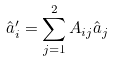Convert formula to latex. <formula><loc_0><loc_0><loc_500><loc_500>\hat { a } _ { i } ^ { \prime } = \sum _ { j = 1 } ^ { 2 } A _ { i j } \hat { a } _ { j }</formula> 